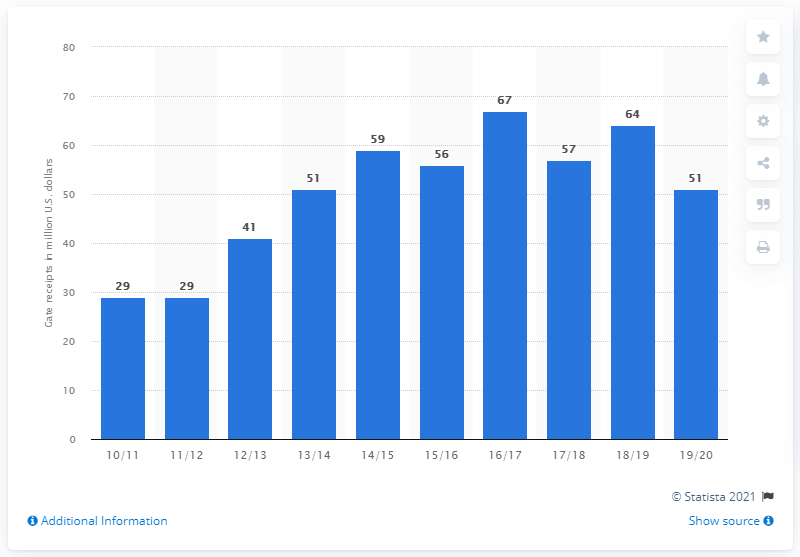Give some essential details in this illustration. The gate receipts of the Los Angeles Clippers for the 2019/20 season were $51 million. 